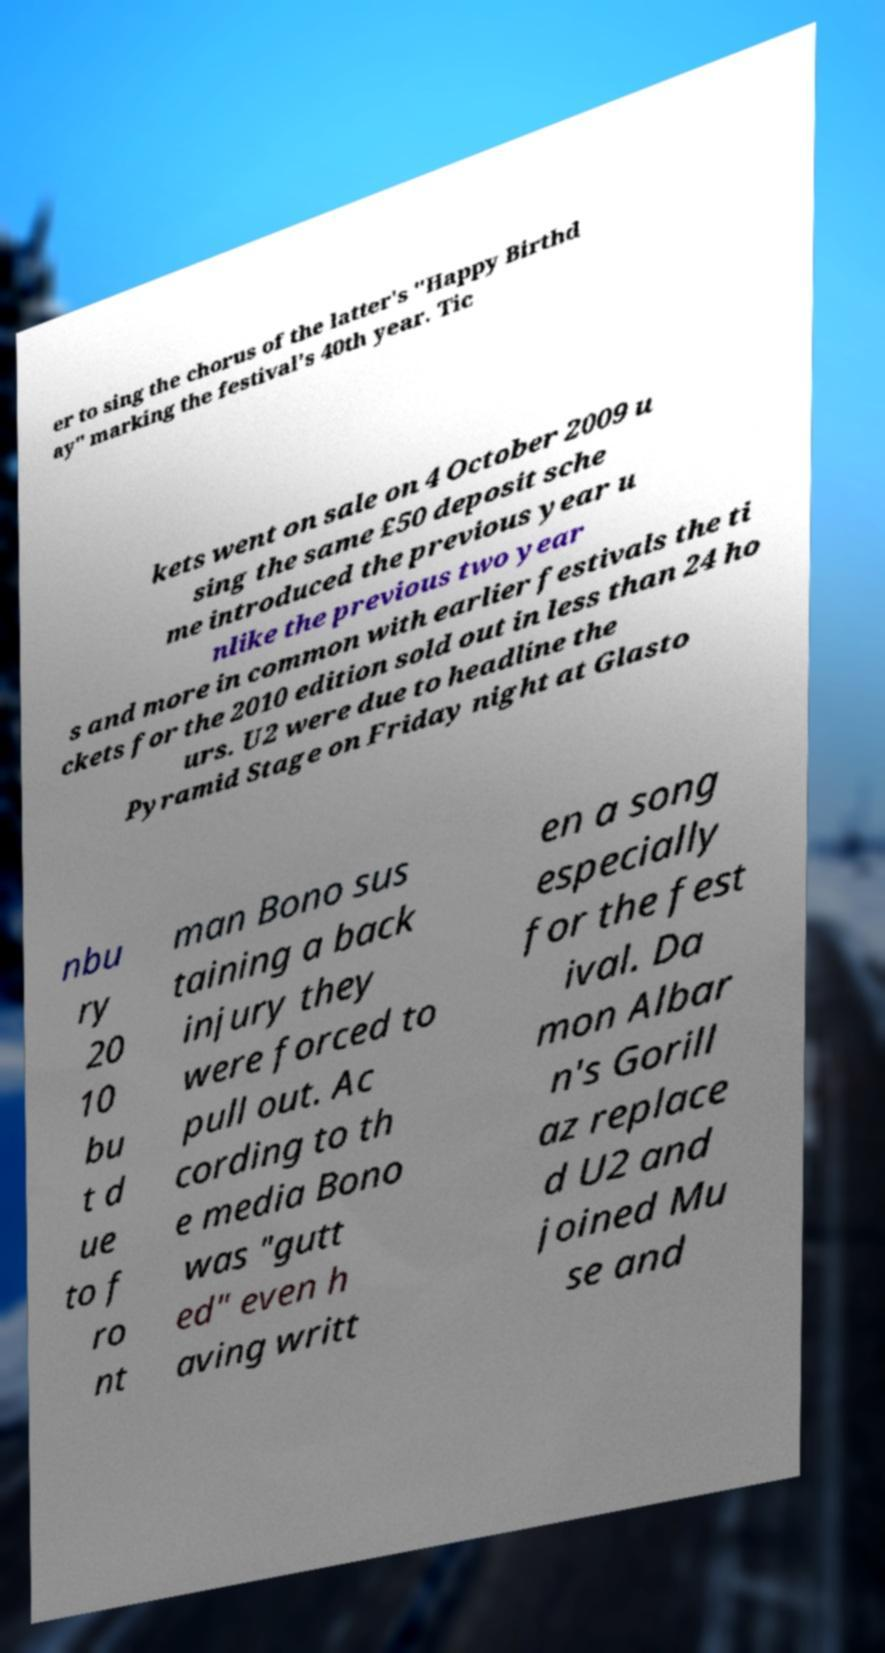Could you assist in decoding the text presented in this image and type it out clearly? er to sing the chorus of the latter's "Happy Birthd ay" marking the festival's 40th year. Tic kets went on sale on 4 October 2009 u sing the same £50 deposit sche me introduced the previous year u nlike the previous two year s and more in common with earlier festivals the ti ckets for the 2010 edition sold out in less than 24 ho urs. U2 were due to headline the Pyramid Stage on Friday night at Glasto nbu ry 20 10 bu t d ue to f ro nt man Bono sus taining a back injury they were forced to pull out. Ac cording to th e media Bono was "gutt ed" even h aving writt en a song especially for the fest ival. Da mon Albar n's Gorill az replace d U2 and joined Mu se and 